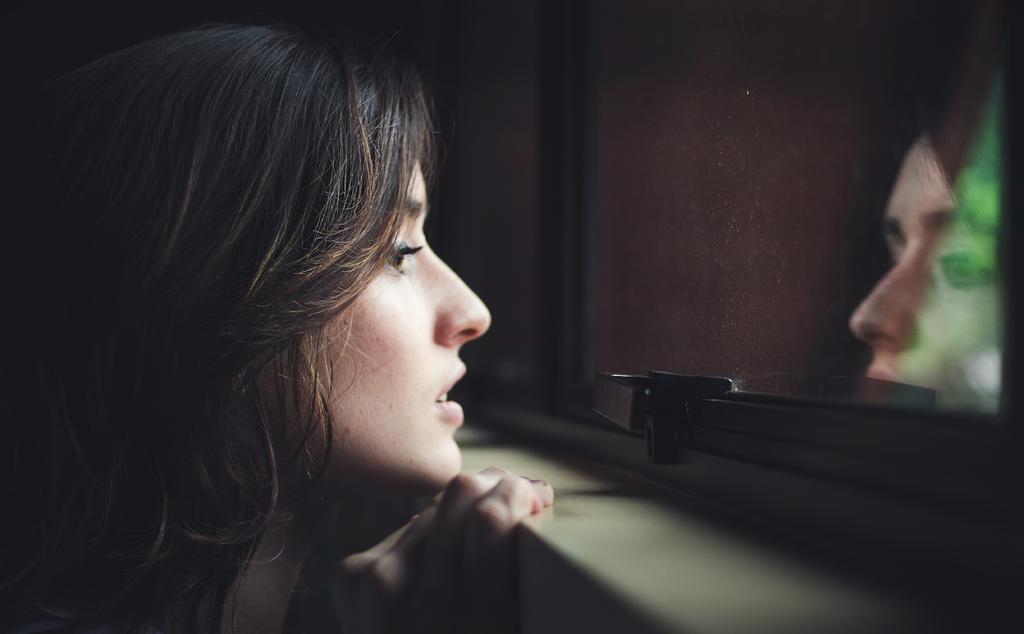Who is present in the image? There is a woman in the image. What object is located on the right side of the image? There is a glass on the right side of the image. What can be seen on the glass in the image? The woman's reflection is visible on the glass. What type of trade is being conducted in the image? There is no indication of any trade being conducted in the image. Is the woman wearing a crown in the image? There is no crown visible on the woman in the image. 